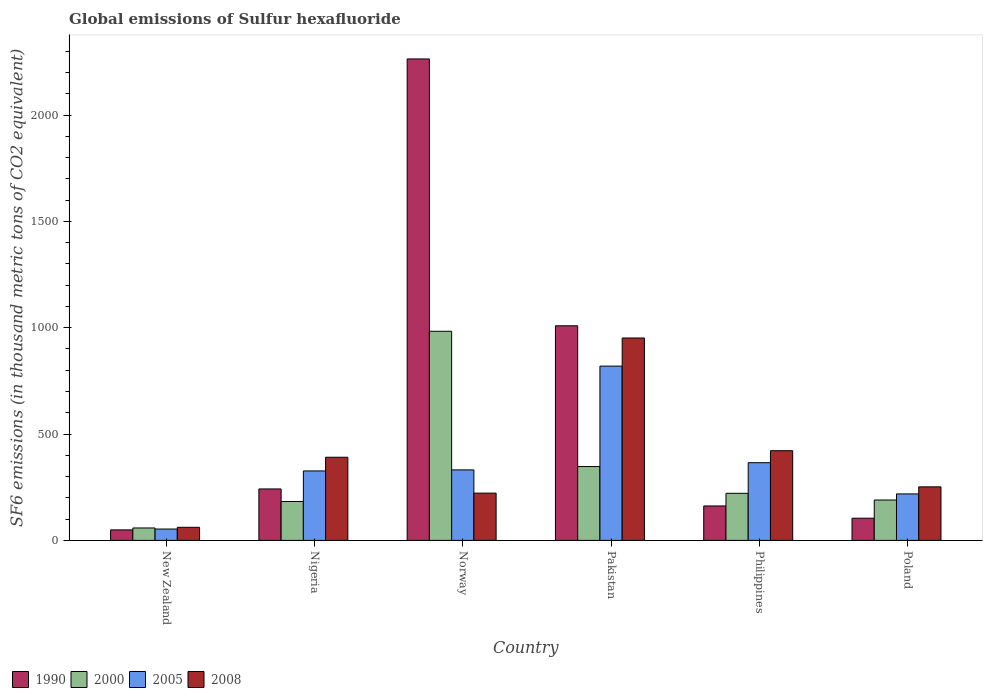How many bars are there on the 3rd tick from the left?
Your response must be concise. 4. What is the global emissions of Sulfur hexafluoride in 2000 in New Zealand?
Offer a terse response. 58.4. Across all countries, what is the maximum global emissions of Sulfur hexafluoride in 2000?
Keep it short and to the point. 983.2. Across all countries, what is the minimum global emissions of Sulfur hexafluoride in 2008?
Your response must be concise. 61.5. In which country was the global emissions of Sulfur hexafluoride in 2005 maximum?
Make the answer very short. Pakistan. In which country was the global emissions of Sulfur hexafluoride in 1990 minimum?
Provide a succinct answer. New Zealand. What is the total global emissions of Sulfur hexafluoride in 2005 in the graph?
Keep it short and to the point. 2114.6. What is the difference between the global emissions of Sulfur hexafluoride in 2000 in Nigeria and that in Poland?
Your answer should be compact. -7. What is the difference between the global emissions of Sulfur hexafluoride in 1990 in Pakistan and the global emissions of Sulfur hexafluoride in 2008 in Nigeria?
Make the answer very short. 618.1. What is the average global emissions of Sulfur hexafluoride in 2005 per country?
Ensure brevity in your answer.  352.43. What is the difference between the global emissions of Sulfur hexafluoride of/in 2008 and global emissions of Sulfur hexafluoride of/in 2000 in Philippines?
Your answer should be compact. 200.3. In how many countries, is the global emissions of Sulfur hexafluoride in 2005 greater than 900 thousand metric tons?
Your answer should be compact. 0. What is the ratio of the global emissions of Sulfur hexafluoride in 2000 in New Zealand to that in Pakistan?
Provide a succinct answer. 0.17. Is the global emissions of Sulfur hexafluoride in 2000 in Nigeria less than that in Norway?
Your answer should be compact. Yes. Is the difference between the global emissions of Sulfur hexafluoride in 2008 in Norway and Philippines greater than the difference between the global emissions of Sulfur hexafluoride in 2000 in Norway and Philippines?
Keep it short and to the point. No. What is the difference between the highest and the second highest global emissions of Sulfur hexafluoride in 2005?
Your answer should be compact. -488. What is the difference between the highest and the lowest global emissions of Sulfur hexafluoride in 2008?
Offer a terse response. 890.1. In how many countries, is the global emissions of Sulfur hexafluoride in 2005 greater than the average global emissions of Sulfur hexafluoride in 2005 taken over all countries?
Your answer should be very brief. 2. Is the sum of the global emissions of Sulfur hexafluoride in 2008 in Nigeria and Norway greater than the maximum global emissions of Sulfur hexafluoride in 1990 across all countries?
Offer a terse response. No. Is it the case that in every country, the sum of the global emissions of Sulfur hexafluoride in 2000 and global emissions of Sulfur hexafluoride in 2005 is greater than the sum of global emissions of Sulfur hexafluoride in 1990 and global emissions of Sulfur hexafluoride in 2008?
Your answer should be compact. No. What is the difference between two consecutive major ticks on the Y-axis?
Keep it short and to the point. 500. Does the graph contain any zero values?
Your answer should be very brief. No. Where does the legend appear in the graph?
Make the answer very short. Bottom left. What is the title of the graph?
Give a very brief answer. Global emissions of Sulfur hexafluoride. What is the label or title of the Y-axis?
Your answer should be compact. SF6 emissions (in thousand metric tons of CO2 equivalent). What is the SF6 emissions (in thousand metric tons of CO2 equivalent) of 1990 in New Zealand?
Provide a succinct answer. 49.4. What is the SF6 emissions (in thousand metric tons of CO2 equivalent) in 2000 in New Zealand?
Your answer should be very brief. 58.4. What is the SF6 emissions (in thousand metric tons of CO2 equivalent) in 2005 in New Zealand?
Offer a terse response. 53.4. What is the SF6 emissions (in thousand metric tons of CO2 equivalent) of 2008 in New Zealand?
Keep it short and to the point. 61.5. What is the SF6 emissions (in thousand metric tons of CO2 equivalent) in 1990 in Nigeria?
Ensure brevity in your answer.  241.9. What is the SF6 emissions (in thousand metric tons of CO2 equivalent) in 2000 in Nigeria?
Your answer should be very brief. 182.8. What is the SF6 emissions (in thousand metric tons of CO2 equivalent) in 2005 in Nigeria?
Your response must be concise. 326.6. What is the SF6 emissions (in thousand metric tons of CO2 equivalent) of 2008 in Nigeria?
Ensure brevity in your answer.  390.9. What is the SF6 emissions (in thousand metric tons of CO2 equivalent) in 1990 in Norway?
Provide a short and direct response. 2263.6. What is the SF6 emissions (in thousand metric tons of CO2 equivalent) in 2000 in Norway?
Ensure brevity in your answer.  983.2. What is the SF6 emissions (in thousand metric tons of CO2 equivalent) in 2005 in Norway?
Provide a succinct answer. 331.4. What is the SF6 emissions (in thousand metric tons of CO2 equivalent) of 2008 in Norway?
Provide a succinct answer. 222.2. What is the SF6 emissions (in thousand metric tons of CO2 equivalent) in 1990 in Pakistan?
Your answer should be compact. 1009. What is the SF6 emissions (in thousand metric tons of CO2 equivalent) of 2000 in Pakistan?
Your answer should be compact. 347.2. What is the SF6 emissions (in thousand metric tons of CO2 equivalent) of 2005 in Pakistan?
Your answer should be compact. 819.4. What is the SF6 emissions (in thousand metric tons of CO2 equivalent) in 2008 in Pakistan?
Ensure brevity in your answer.  951.6. What is the SF6 emissions (in thousand metric tons of CO2 equivalent) in 1990 in Philippines?
Ensure brevity in your answer.  161.9. What is the SF6 emissions (in thousand metric tons of CO2 equivalent) of 2000 in Philippines?
Your answer should be compact. 221.4. What is the SF6 emissions (in thousand metric tons of CO2 equivalent) of 2005 in Philippines?
Offer a very short reply. 365.3. What is the SF6 emissions (in thousand metric tons of CO2 equivalent) of 2008 in Philippines?
Ensure brevity in your answer.  421.7. What is the SF6 emissions (in thousand metric tons of CO2 equivalent) of 1990 in Poland?
Your response must be concise. 104.3. What is the SF6 emissions (in thousand metric tons of CO2 equivalent) in 2000 in Poland?
Offer a terse response. 189.8. What is the SF6 emissions (in thousand metric tons of CO2 equivalent) in 2005 in Poland?
Make the answer very short. 218.5. What is the SF6 emissions (in thousand metric tons of CO2 equivalent) in 2008 in Poland?
Your answer should be compact. 251.7. Across all countries, what is the maximum SF6 emissions (in thousand metric tons of CO2 equivalent) in 1990?
Give a very brief answer. 2263.6. Across all countries, what is the maximum SF6 emissions (in thousand metric tons of CO2 equivalent) in 2000?
Offer a terse response. 983.2. Across all countries, what is the maximum SF6 emissions (in thousand metric tons of CO2 equivalent) in 2005?
Give a very brief answer. 819.4. Across all countries, what is the maximum SF6 emissions (in thousand metric tons of CO2 equivalent) of 2008?
Your response must be concise. 951.6. Across all countries, what is the minimum SF6 emissions (in thousand metric tons of CO2 equivalent) of 1990?
Offer a very short reply. 49.4. Across all countries, what is the minimum SF6 emissions (in thousand metric tons of CO2 equivalent) in 2000?
Keep it short and to the point. 58.4. Across all countries, what is the minimum SF6 emissions (in thousand metric tons of CO2 equivalent) in 2005?
Your answer should be compact. 53.4. Across all countries, what is the minimum SF6 emissions (in thousand metric tons of CO2 equivalent) of 2008?
Your answer should be compact. 61.5. What is the total SF6 emissions (in thousand metric tons of CO2 equivalent) in 1990 in the graph?
Your response must be concise. 3830.1. What is the total SF6 emissions (in thousand metric tons of CO2 equivalent) of 2000 in the graph?
Keep it short and to the point. 1982.8. What is the total SF6 emissions (in thousand metric tons of CO2 equivalent) of 2005 in the graph?
Give a very brief answer. 2114.6. What is the total SF6 emissions (in thousand metric tons of CO2 equivalent) of 2008 in the graph?
Give a very brief answer. 2299.6. What is the difference between the SF6 emissions (in thousand metric tons of CO2 equivalent) of 1990 in New Zealand and that in Nigeria?
Provide a short and direct response. -192.5. What is the difference between the SF6 emissions (in thousand metric tons of CO2 equivalent) in 2000 in New Zealand and that in Nigeria?
Provide a short and direct response. -124.4. What is the difference between the SF6 emissions (in thousand metric tons of CO2 equivalent) of 2005 in New Zealand and that in Nigeria?
Your answer should be very brief. -273.2. What is the difference between the SF6 emissions (in thousand metric tons of CO2 equivalent) of 2008 in New Zealand and that in Nigeria?
Provide a short and direct response. -329.4. What is the difference between the SF6 emissions (in thousand metric tons of CO2 equivalent) in 1990 in New Zealand and that in Norway?
Your response must be concise. -2214.2. What is the difference between the SF6 emissions (in thousand metric tons of CO2 equivalent) in 2000 in New Zealand and that in Norway?
Your answer should be compact. -924.8. What is the difference between the SF6 emissions (in thousand metric tons of CO2 equivalent) in 2005 in New Zealand and that in Norway?
Provide a succinct answer. -278. What is the difference between the SF6 emissions (in thousand metric tons of CO2 equivalent) of 2008 in New Zealand and that in Norway?
Ensure brevity in your answer.  -160.7. What is the difference between the SF6 emissions (in thousand metric tons of CO2 equivalent) in 1990 in New Zealand and that in Pakistan?
Provide a succinct answer. -959.6. What is the difference between the SF6 emissions (in thousand metric tons of CO2 equivalent) of 2000 in New Zealand and that in Pakistan?
Give a very brief answer. -288.8. What is the difference between the SF6 emissions (in thousand metric tons of CO2 equivalent) in 2005 in New Zealand and that in Pakistan?
Provide a succinct answer. -766. What is the difference between the SF6 emissions (in thousand metric tons of CO2 equivalent) in 2008 in New Zealand and that in Pakistan?
Your response must be concise. -890.1. What is the difference between the SF6 emissions (in thousand metric tons of CO2 equivalent) in 1990 in New Zealand and that in Philippines?
Your answer should be compact. -112.5. What is the difference between the SF6 emissions (in thousand metric tons of CO2 equivalent) in 2000 in New Zealand and that in Philippines?
Offer a very short reply. -163. What is the difference between the SF6 emissions (in thousand metric tons of CO2 equivalent) in 2005 in New Zealand and that in Philippines?
Ensure brevity in your answer.  -311.9. What is the difference between the SF6 emissions (in thousand metric tons of CO2 equivalent) in 2008 in New Zealand and that in Philippines?
Offer a terse response. -360.2. What is the difference between the SF6 emissions (in thousand metric tons of CO2 equivalent) in 1990 in New Zealand and that in Poland?
Make the answer very short. -54.9. What is the difference between the SF6 emissions (in thousand metric tons of CO2 equivalent) in 2000 in New Zealand and that in Poland?
Give a very brief answer. -131.4. What is the difference between the SF6 emissions (in thousand metric tons of CO2 equivalent) of 2005 in New Zealand and that in Poland?
Provide a short and direct response. -165.1. What is the difference between the SF6 emissions (in thousand metric tons of CO2 equivalent) of 2008 in New Zealand and that in Poland?
Offer a terse response. -190.2. What is the difference between the SF6 emissions (in thousand metric tons of CO2 equivalent) of 1990 in Nigeria and that in Norway?
Keep it short and to the point. -2021.7. What is the difference between the SF6 emissions (in thousand metric tons of CO2 equivalent) in 2000 in Nigeria and that in Norway?
Offer a terse response. -800.4. What is the difference between the SF6 emissions (in thousand metric tons of CO2 equivalent) of 2005 in Nigeria and that in Norway?
Your answer should be compact. -4.8. What is the difference between the SF6 emissions (in thousand metric tons of CO2 equivalent) of 2008 in Nigeria and that in Norway?
Offer a very short reply. 168.7. What is the difference between the SF6 emissions (in thousand metric tons of CO2 equivalent) of 1990 in Nigeria and that in Pakistan?
Provide a succinct answer. -767.1. What is the difference between the SF6 emissions (in thousand metric tons of CO2 equivalent) of 2000 in Nigeria and that in Pakistan?
Keep it short and to the point. -164.4. What is the difference between the SF6 emissions (in thousand metric tons of CO2 equivalent) in 2005 in Nigeria and that in Pakistan?
Provide a succinct answer. -492.8. What is the difference between the SF6 emissions (in thousand metric tons of CO2 equivalent) of 2008 in Nigeria and that in Pakistan?
Ensure brevity in your answer.  -560.7. What is the difference between the SF6 emissions (in thousand metric tons of CO2 equivalent) in 2000 in Nigeria and that in Philippines?
Your answer should be very brief. -38.6. What is the difference between the SF6 emissions (in thousand metric tons of CO2 equivalent) in 2005 in Nigeria and that in Philippines?
Ensure brevity in your answer.  -38.7. What is the difference between the SF6 emissions (in thousand metric tons of CO2 equivalent) of 2008 in Nigeria and that in Philippines?
Offer a very short reply. -30.8. What is the difference between the SF6 emissions (in thousand metric tons of CO2 equivalent) of 1990 in Nigeria and that in Poland?
Offer a terse response. 137.6. What is the difference between the SF6 emissions (in thousand metric tons of CO2 equivalent) in 2000 in Nigeria and that in Poland?
Offer a very short reply. -7. What is the difference between the SF6 emissions (in thousand metric tons of CO2 equivalent) of 2005 in Nigeria and that in Poland?
Your answer should be compact. 108.1. What is the difference between the SF6 emissions (in thousand metric tons of CO2 equivalent) of 2008 in Nigeria and that in Poland?
Make the answer very short. 139.2. What is the difference between the SF6 emissions (in thousand metric tons of CO2 equivalent) in 1990 in Norway and that in Pakistan?
Your answer should be compact. 1254.6. What is the difference between the SF6 emissions (in thousand metric tons of CO2 equivalent) of 2000 in Norway and that in Pakistan?
Keep it short and to the point. 636. What is the difference between the SF6 emissions (in thousand metric tons of CO2 equivalent) of 2005 in Norway and that in Pakistan?
Provide a succinct answer. -488. What is the difference between the SF6 emissions (in thousand metric tons of CO2 equivalent) in 2008 in Norway and that in Pakistan?
Give a very brief answer. -729.4. What is the difference between the SF6 emissions (in thousand metric tons of CO2 equivalent) of 1990 in Norway and that in Philippines?
Your answer should be compact. 2101.7. What is the difference between the SF6 emissions (in thousand metric tons of CO2 equivalent) in 2000 in Norway and that in Philippines?
Ensure brevity in your answer.  761.8. What is the difference between the SF6 emissions (in thousand metric tons of CO2 equivalent) in 2005 in Norway and that in Philippines?
Provide a succinct answer. -33.9. What is the difference between the SF6 emissions (in thousand metric tons of CO2 equivalent) of 2008 in Norway and that in Philippines?
Give a very brief answer. -199.5. What is the difference between the SF6 emissions (in thousand metric tons of CO2 equivalent) of 1990 in Norway and that in Poland?
Offer a very short reply. 2159.3. What is the difference between the SF6 emissions (in thousand metric tons of CO2 equivalent) of 2000 in Norway and that in Poland?
Provide a short and direct response. 793.4. What is the difference between the SF6 emissions (in thousand metric tons of CO2 equivalent) in 2005 in Norway and that in Poland?
Offer a terse response. 112.9. What is the difference between the SF6 emissions (in thousand metric tons of CO2 equivalent) of 2008 in Norway and that in Poland?
Your answer should be compact. -29.5. What is the difference between the SF6 emissions (in thousand metric tons of CO2 equivalent) in 1990 in Pakistan and that in Philippines?
Make the answer very short. 847.1. What is the difference between the SF6 emissions (in thousand metric tons of CO2 equivalent) in 2000 in Pakistan and that in Philippines?
Give a very brief answer. 125.8. What is the difference between the SF6 emissions (in thousand metric tons of CO2 equivalent) of 2005 in Pakistan and that in Philippines?
Give a very brief answer. 454.1. What is the difference between the SF6 emissions (in thousand metric tons of CO2 equivalent) of 2008 in Pakistan and that in Philippines?
Your answer should be compact. 529.9. What is the difference between the SF6 emissions (in thousand metric tons of CO2 equivalent) in 1990 in Pakistan and that in Poland?
Your answer should be very brief. 904.7. What is the difference between the SF6 emissions (in thousand metric tons of CO2 equivalent) of 2000 in Pakistan and that in Poland?
Offer a terse response. 157.4. What is the difference between the SF6 emissions (in thousand metric tons of CO2 equivalent) in 2005 in Pakistan and that in Poland?
Provide a succinct answer. 600.9. What is the difference between the SF6 emissions (in thousand metric tons of CO2 equivalent) of 2008 in Pakistan and that in Poland?
Ensure brevity in your answer.  699.9. What is the difference between the SF6 emissions (in thousand metric tons of CO2 equivalent) of 1990 in Philippines and that in Poland?
Offer a terse response. 57.6. What is the difference between the SF6 emissions (in thousand metric tons of CO2 equivalent) in 2000 in Philippines and that in Poland?
Give a very brief answer. 31.6. What is the difference between the SF6 emissions (in thousand metric tons of CO2 equivalent) of 2005 in Philippines and that in Poland?
Ensure brevity in your answer.  146.8. What is the difference between the SF6 emissions (in thousand metric tons of CO2 equivalent) of 2008 in Philippines and that in Poland?
Offer a terse response. 170. What is the difference between the SF6 emissions (in thousand metric tons of CO2 equivalent) of 1990 in New Zealand and the SF6 emissions (in thousand metric tons of CO2 equivalent) of 2000 in Nigeria?
Offer a terse response. -133.4. What is the difference between the SF6 emissions (in thousand metric tons of CO2 equivalent) in 1990 in New Zealand and the SF6 emissions (in thousand metric tons of CO2 equivalent) in 2005 in Nigeria?
Offer a terse response. -277.2. What is the difference between the SF6 emissions (in thousand metric tons of CO2 equivalent) in 1990 in New Zealand and the SF6 emissions (in thousand metric tons of CO2 equivalent) in 2008 in Nigeria?
Offer a very short reply. -341.5. What is the difference between the SF6 emissions (in thousand metric tons of CO2 equivalent) in 2000 in New Zealand and the SF6 emissions (in thousand metric tons of CO2 equivalent) in 2005 in Nigeria?
Keep it short and to the point. -268.2. What is the difference between the SF6 emissions (in thousand metric tons of CO2 equivalent) in 2000 in New Zealand and the SF6 emissions (in thousand metric tons of CO2 equivalent) in 2008 in Nigeria?
Your answer should be compact. -332.5. What is the difference between the SF6 emissions (in thousand metric tons of CO2 equivalent) of 2005 in New Zealand and the SF6 emissions (in thousand metric tons of CO2 equivalent) of 2008 in Nigeria?
Keep it short and to the point. -337.5. What is the difference between the SF6 emissions (in thousand metric tons of CO2 equivalent) of 1990 in New Zealand and the SF6 emissions (in thousand metric tons of CO2 equivalent) of 2000 in Norway?
Provide a succinct answer. -933.8. What is the difference between the SF6 emissions (in thousand metric tons of CO2 equivalent) of 1990 in New Zealand and the SF6 emissions (in thousand metric tons of CO2 equivalent) of 2005 in Norway?
Your response must be concise. -282. What is the difference between the SF6 emissions (in thousand metric tons of CO2 equivalent) in 1990 in New Zealand and the SF6 emissions (in thousand metric tons of CO2 equivalent) in 2008 in Norway?
Your answer should be compact. -172.8. What is the difference between the SF6 emissions (in thousand metric tons of CO2 equivalent) in 2000 in New Zealand and the SF6 emissions (in thousand metric tons of CO2 equivalent) in 2005 in Norway?
Ensure brevity in your answer.  -273. What is the difference between the SF6 emissions (in thousand metric tons of CO2 equivalent) in 2000 in New Zealand and the SF6 emissions (in thousand metric tons of CO2 equivalent) in 2008 in Norway?
Ensure brevity in your answer.  -163.8. What is the difference between the SF6 emissions (in thousand metric tons of CO2 equivalent) of 2005 in New Zealand and the SF6 emissions (in thousand metric tons of CO2 equivalent) of 2008 in Norway?
Ensure brevity in your answer.  -168.8. What is the difference between the SF6 emissions (in thousand metric tons of CO2 equivalent) in 1990 in New Zealand and the SF6 emissions (in thousand metric tons of CO2 equivalent) in 2000 in Pakistan?
Ensure brevity in your answer.  -297.8. What is the difference between the SF6 emissions (in thousand metric tons of CO2 equivalent) of 1990 in New Zealand and the SF6 emissions (in thousand metric tons of CO2 equivalent) of 2005 in Pakistan?
Provide a short and direct response. -770. What is the difference between the SF6 emissions (in thousand metric tons of CO2 equivalent) of 1990 in New Zealand and the SF6 emissions (in thousand metric tons of CO2 equivalent) of 2008 in Pakistan?
Offer a very short reply. -902.2. What is the difference between the SF6 emissions (in thousand metric tons of CO2 equivalent) of 2000 in New Zealand and the SF6 emissions (in thousand metric tons of CO2 equivalent) of 2005 in Pakistan?
Your response must be concise. -761. What is the difference between the SF6 emissions (in thousand metric tons of CO2 equivalent) of 2000 in New Zealand and the SF6 emissions (in thousand metric tons of CO2 equivalent) of 2008 in Pakistan?
Your response must be concise. -893.2. What is the difference between the SF6 emissions (in thousand metric tons of CO2 equivalent) in 2005 in New Zealand and the SF6 emissions (in thousand metric tons of CO2 equivalent) in 2008 in Pakistan?
Make the answer very short. -898.2. What is the difference between the SF6 emissions (in thousand metric tons of CO2 equivalent) of 1990 in New Zealand and the SF6 emissions (in thousand metric tons of CO2 equivalent) of 2000 in Philippines?
Your response must be concise. -172. What is the difference between the SF6 emissions (in thousand metric tons of CO2 equivalent) in 1990 in New Zealand and the SF6 emissions (in thousand metric tons of CO2 equivalent) in 2005 in Philippines?
Provide a short and direct response. -315.9. What is the difference between the SF6 emissions (in thousand metric tons of CO2 equivalent) in 1990 in New Zealand and the SF6 emissions (in thousand metric tons of CO2 equivalent) in 2008 in Philippines?
Offer a very short reply. -372.3. What is the difference between the SF6 emissions (in thousand metric tons of CO2 equivalent) in 2000 in New Zealand and the SF6 emissions (in thousand metric tons of CO2 equivalent) in 2005 in Philippines?
Your response must be concise. -306.9. What is the difference between the SF6 emissions (in thousand metric tons of CO2 equivalent) of 2000 in New Zealand and the SF6 emissions (in thousand metric tons of CO2 equivalent) of 2008 in Philippines?
Offer a terse response. -363.3. What is the difference between the SF6 emissions (in thousand metric tons of CO2 equivalent) of 2005 in New Zealand and the SF6 emissions (in thousand metric tons of CO2 equivalent) of 2008 in Philippines?
Make the answer very short. -368.3. What is the difference between the SF6 emissions (in thousand metric tons of CO2 equivalent) of 1990 in New Zealand and the SF6 emissions (in thousand metric tons of CO2 equivalent) of 2000 in Poland?
Your answer should be very brief. -140.4. What is the difference between the SF6 emissions (in thousand metric tons of CO2 equivalent) of 1990 in New Zealand and the SF6 emissions (in thousand metric tons of CO2 equivalent) of 2005 in Poland?
Keep it short and to the point. -169.1. What is the difference between the SF6 emissions (in thousand metric tons of CO2 equivalent) in 1990 in New Zealand and the SF6 emissions (in thousand metric tons of CO2 equivalent) in 2008 in Poland?
Provide a short and direct response. -202.3. What is the difference between the SF6 emissions (in thousand metric tons of CO2 equivalent) of 2000 in New Zealand and the SF6 emissions (in thousand metric tons of CO2 equivalent) of 2005 in Poland?
Make the answer very short. -160.1. What is the difference between the SF6 emissions (in thousand metric tons of CO2 equivalent) in 2000 in New Zealand and the SF6 emissions (in thousand metric tons of CO2 equivalent) in 2008 in Poland?
Make the answer very short. -193.3. What is the difference between the SF6 emissions (in thousand metric tons of CO2 equivalent) in 2005 in New Zealand and the SF6 emissions (in thousand metric tons of CO2 equivalent) in 2008 in Poland?
Provide a succinct answer. -198.3. What is the difference between the SF6 emissions (in thousand metric tons of CO2 equivalent) of 1990 in Nigeria and the SF6 emissions (in thousand metric tons of CO2 equivalent) of 2000 in Norway?
Give a very brief answer. -741.3. What is the difference between the SF6 emissions (in thousand metric tons of CO2 equivalent) in 1990 in Nigeria and the SF6 emissions (in thousand metric tons of CO2 equivalent) in 2005 in Norway?
Make the answer very short. -89.5. What is the difference between the SF6 emissions (in thousand metric tons of CO2 equivalent) of 2000 in Nigeria and the SF6 emissions (in thousand metric tons of CO2 equivalent) of 2005 in Norway?
Your response must be concise. -148.6. What is the difference between the SF6 emissions (in thousand metric tons of CO2 equivalent) of 2000 in Nigeria and the SF6 emissions (in thousand metric tons of CO2 equivalent) of 2008 in Norway?
Keep it short and to the point. -39.4. What is the difference between the SF6 emissions (in thousand metric tons of CO2 equivalent) in 2005 in Nigeria and the SF6 emissions (in thousand metric tons of CO2 equivalent) in 2008 in Norway?
Provide a short and direct response. 104.4. What is the difference between the SF6 emissions (in thousand metric tons of CO2 equivalent) of 1990 in Nigeria and the SF6 emissions (in thousand metric tons of CO2 equivalent) of 2000 in Pakistan?
Your answer should be compact. -105.3. What is the difference between the SF6 emissions (in thousand metric tons of CO2 equivalent) in 1990 in Nigeria and the SF6 emissions (in thousand metric tons of CO2 equivalent) in 2005 in Pakistan?
Offer a very short reply. -577.5. What is the difference between the SF6 emissions (in thousand metric tons of CO2 equivalent) in 1990 in Nigeria and the SF6 emissions (in thousand metric tons of CO2 equivalent) in 2008 in Pakistan?
Keep it short and to the point. -709.7. What is the difference between the SF6 emissions (in thousand metric tons of CO2 equivalent) in 2000 in Nigeria and the SF6 emissions (in thousand metric tons of CO2 equivalent) in 2005 in Pakistan?
Ensure brevity in your answer.  -636.6. What is the difference between the SF6 emissions (in thousand metric tons of CO2 equivalent) of 2000 in Nigeria and the SF6 emissions (in thousand metric tons of CO2 equivalent) of 2008 in Pakistan?
Your response must be concise. -768.8. What is the difference between the SF6 emissions (in thousand metric tons of CO2 equivalent) in 2005 in Nigeria and the SF6 emissions (in thousand metric tons of CO2 equivalent) in 2008 in Pakistan?
Your answer should be compact. -625. What is the difference between the SF6 emissions (in thousand metric tons of CO2 equivalent) in 1990 in Nigeria and the SF6 emissions (in thousand metric tons of CO2 equivalent) in 2000 in Philippines?
Keep it short and to the point. 20.5. What is the difference between the SF6 emissions (in thousand metric tons of CO2 equivalent) in 1990 in Nigeria and the SF6 emissions (in thousand metric tons of CO2 equivalent) in 2005 in Philippines?
Offer a terse response. -123.4. What is the difference between the SF6 emissions (in thousand metric tons of CO2 equivalent) of 1990 in Nigeria and the SF6 emissions (in thousand metric tons of CO2 equivalent) of 2008 in Philippines?
Provide a short and direct response. -179.8. What is the difference between the SF6 emissions (in thousand metric tons of CO2 equivalent) of 2000 in Nigeria and the SF6 emissions (in thousand metric tons of CO2 equivalent) of 2005 in Philippines?
Ensure brevity in your answer.  -182.5. What is the difference between the SF6 emissions (in thousand metric tons of CO2 equivalent) in 2000 in Nigeria and the SF6 emissions (in thousand metric tons of CO2 equivalent) in 2008 in Philippines?
Give a very brief answer. -238.9. What is the difference between the SF6 emissions (in thousand metric tons of CO2 equivalent) in 2005 in Nigeria and the SF6 emissions (in thousand metric tons of CO2 equivalent) in 2008 in Philippines?
Make the answer very short. -95.1. What is the difference between the SF6 emissions (in thousand metric tons of CO2 equivalent) in 1990 in Nigeria and the SF6 emissions (in thousand metric tons of CO2 equivalent) in 2000 in Poland?
Your response must be concise. 52.1. What is the difference between the SF6 emissions (in thousand metric tons of CO2 equivalent) of 1990 in Nigeria and the SF6 emissions (in thousand metric tons of CO2 equivalent) of 2005 in Poland?
Your answer should be very brief. 23.4. What is the difference between the SF6 emissions (in thousand metric tons of CO2 equivalent) in 1990 in Nigeria and the SF6 emissions (in thousand metric tons of CO2 equivalent) in 2008 in Poland?
Offer a very short reply. -9.8. What is the difference between the SF6 emissions (in thousand metric tons of CO2 equivalent) of 2000 in Nigeria and the SF6 emissions (in thousand metric tons of CO2 equivalent) of 2005 in Poland?
Keep it short and to the point. -35.7. What is the difference between the SF6 emissions (in thousand metric tons of CO2 equivalent) of 2000 in Nigeria and the SF6 emissions (in thousand metric tons of CO2 equivalent) of 2008 in Poland?
Provide a short and direct response. -68.9. What is the difference between the SF6 emissions (in thousand metric tons of CO2 equivalent) in 2005 in Nigeria and the SF6 emissions (in thousand metric tons of CO2 equivalent) in 2008 in Poland?
Make the answer very short. 74.9. What is the difference between the SF6 emissions (in thousand metric tons of CO2 equivalent) of 1990 in Norway and the SF6 emissions (in thousand metric tons of CO2 equivalent) of 2000 in Pakistan?
Ensure brevity in your answer.  1916.4. What is the difference between the SF6 emissions (in thousand metric tons of CO2 equivalent) in 1990 in Norway and the SF6 emissions (in thousand metric tons of CO2 equivalent) in 2005 in Pakistan?
Your answer should be compact. 1444.2. What is the difference between the SF6 emissions (in thousand metric tons of CO2 equivalent) in 1990 in Norway and the SF6 emissions (in thousand metric tons of CO2 equivalent) in 2008 in Pakistan?
Provide a succinct answer. 1312. What is the difference between the SF6 emissions (in thousand metric tons of CO2 equivalent) in 2000 in Norway and the SF6 emissions (in thousand metric tons of CO2 equivalent) in 2005 in Pakistan?
Provide a succinct answer. 163.8. What is the difference between the SF6 emissions (in thousand metric tons of CO2 equivalent) in 2000 in Norway and the SF6 emissions (in thousand metric tons of CO2 equivalent) in 2008 in Pakistan?
Provide a succinct answer. 31.6. What is the difference between the SF6 emissions (in thousand metric tons of CO2 equivalent) in 2005 in Norway and the SF6 emissions (in thousand metric tons of CO2 equivalent) in 2008 in Pakistan?
Ensure brevity in your answer.  -620.2. What is the difference between the SF6 emissions (in thousand metric tons of CO2 equivalent) of 1990 in Norway and the SF6 emissions (in thousand metric tons of CO2 equivalent) of 2000 in Philippines?
Make the answer very short. 2042.2. What is the difference between the SF6 emissions (in thousand metric tons of CO2 equivalent) in 1990 in Norway and the SF6 emissions (in thousand metric tons of CO2 equivalent) in 2005 in Philippines?
Make the answer very short. 1898.3. What is the difference between the SF6 emissions (in thousand metric tons of CO2 equivalent) of 1990 in Norway and the SF6 emissions (in thousand metric tons of CO2 equivalent) of 2008 in Philippines?
Your answer should be compact. 1841.9. What is the difference between the SF6 emissions (in thousand metric tons of CO2 equivalent) of 2000 in Norway and the SF6 emissions (in thousand metric tons of CO2 equivalent) of 2005 in Philippines?
Offer a terse response. 617.9. What is the difference between the SF6 emissions (in thousand metric tons of CO2 equivalent) in 2000 in Norway and the SF6 emissions (in thousand metric tons of CO2 equivalent) in 2008 in Philippines?
Make the answer very short. 561.5. What is the difference between the SF6 emissions (in thousand metric tons of CO2 equivalent) in 2005 in Norway and the SF6 emissions (in thousand metric tons of CO2 equivalent) in 2008 in Philippines?
Offer a very short reply. -90.3. What is the difference between the SF6 emissions (in thousand metric tons of CO2 equivalent) of 1990 in Norway and the SF6 emissions (in thousand metric tons of CO2 equivalent) of 2000 in Poland?
Ensure brevity in your answer.  2073.8. What is the difference between the SF6 emissions (in thousand metric tons of CO2 equivalent) in 1990 in Norway and the SF6 emissions (in thousand metric tons of CO2 equivalent) in 2005 in Poland?
Ensure brevity in your answer.  2045.1. What is the difference between the SF6 emissions (in thousand metric tons of CO2 equivalent) in 1990 in Norway and the SF6 emissions (in thousand metric tons of CO2 equivalent) in 2008 in Poland?
Give a very brief answer. 2011.9. What is the difference between the SF6 emissions (in thousand metric tons of CO2 equivalent) of 2000 in Norway and the SF6 emissions (in thousand metric tons of CO2 equivalent) of 2005 in Poland?
Your response must be concise. 764.7. What is the difference between the SF6 emissions (in thousand metric tons of CO2 equivalent) of 2000 in Norway and the SF6 emissions (in thousand metric tons of CO2 equivalent) of 2008 in Poland?
Give a very brief answer. 731.5. What is the difference between the SF6 emissions (in thousand metric tons of CO2 equivalent) in 2005 in Norway and the SF6 emissions (in thousand metric tons of CO2 equivalent) in 2008 in Poland?
Your answer should be compact. 79.7. What is the difference between the SF6 emissions (in thousand metric tons of CO2 equivalent) of 1990 in Pakistan and the SF6 emissions (in thousand metric tons of CO2 equivalent) of 2000 in Philippines?
Ensure brevity in your answer.  787.6. What is the difference between the SF6 emissions (in thousand metric tons of CO2 equivalent) of 1990 in Pakistan and the SF6 emissions (in thousand metric tons of CO2 equivalent) of 2005 in Philippines?
Your response must be concise. 643.7. What is the difference between the SF6 emissions (in thousand metric tons of CO2 equivalent) of 1990 in Pakistan and the SF6 emissions (in thousand metric tons of CO2 equivalent) of 2008 in Philippines?
Your answer should be compact. 587.3. What is the difference between the SF6 emissions (in thousand metric tons of CO2 equivalent) in 2000 in Pakistan and the SF6 emissions (in thousand metric tons of CO2 equivalent) in 2005 in Philippines?
Provide a succinct answer. -18.1. What is the difference between the SF6 emissions (in thousand metric tons of CO2 equivalent) of 2000 in Pakistan and the SF6 emissions (in thousand metric tons of CO2 equivalent) of 2008 in Philippines?
Offer a terse response. -74.5. What is the difference between the SF6 emissions (in thousand metric tons of CO2 equivalent) in 2005 in Pakistan and the SF6 emissions (in thousand metric tons of CO2 equivalent) in 2008 in Philippines?
Provide a short and direct response. 397.7. What is the difference between the SF6 emissions (in thousand metric tons of CO2 equivalent) in 1990 in Pakistan and the SF6 emissions (in thousand metric tons of CO2 equivalent) in 2000 in Poland?
Provide a succinct answer. 819.2. What is the difference between the SF6 emissions (in thousand metric tons of CO2 equivalent) of 1990 in Pakistan and the SF6 emissions (in thousand metric tons of CO2 equivalent) of 2005 in Poland?
Give a very brief answer. 790.5. What is the difference between the SF6 emissions (in thousand metric tons of CO2 equivalent) of 1990 in Pakistan and the SF6 emissions (in thousand metric tons of CO2 equivalent) of 2008 in Poland?
Provide a succinct answer. 757.3. What is the difference between the SF6 emissions (in thousand metric tons of CO2 equivalent) of 2000 in Pakistan and the SF6 emissions (in thousand metric tons of CO2 equivalent) of 2005 in Poland?
Provide a succinct answer. 128.7. What is the difference between the SF6 emissions (in thousand metric tons of CO2 equivalent) of 2000 in Pakistan and the SF6 emissions (in thousand metric tons of CO2 equivalent) of 2008 in Poland?
Keep it short and to the point. 95.5. What is the difference between the SF6 emissions (in thousand metric tons of CO2 equivalent) in 2005 in Pakistan and the SF6 emissions (in thousand metric tons of CO2 equivalent) in 2008 in Poland?
Offer a terse response. 567.7. What is the difference between the SF6 emissions (in thousand metric tons of CO2 equivalent) in 1990 in Philippines and the SF6 emissions (in thousand metric tons of CO2 equivalent) in 2000 in Poland?
Your response must be concise. -27.9. What is the difference between the SF6 emissions (in thousand metric tons of CO2 equivalent) in 1990 in Philippines and the SF6 emissions (in thousand metric tons of CO2 equivalent) in 2005 in Poland?
Ensure brevity in your answer.  -56.6. What is the difference between the SF6 emissions (in thousand metric tons of CO2 equivalent) in 1990 in Philippines and the SF6 emissions (in thousand metric tons of CO2 equivalent) in 2008 in Poland?
Provide a succinct answer. -89.8. What is the difference between the SF6 emissions (in thousand metric tons of CO2 equivalent) in 2000 in Philippines and the SF6 emissions (in thousand metric tons of CO2 equivalent) in 2005 in Poland?
Offer a terse response. 2.9. What is the difference between the SF6 emissions (in thousand metric tons of CO2 equivalent) of 2000 in Philippines and the SF6 emissions (in thousand metric tons of CO2 equivalent) of 2008 in Poland?
Offer a terse response. -30.3. What is the difference between the SF6 emissions (in thousand metric tons of CO2 equivalent) in 2005 in Philippines and the SF6 emissions (in thousand metric tons of CO2 equivalent) in 2008 in Poland?
Offer a terse response. 113.6. What is the average SF6 emissions (in thousand metric tons of CO2 equivalent) in 1990 per country?
Your answer should be compact. 638.35. What is the average SF6 emissions (in thousand metric tons of CO2 equivalent) in 2000 per country?
Provide a short and direct response. 330.47. What is the average SF6 emissions (in thousand metric tons of CO2 equivalent) of 2005 per country?
Make the answer very short. 352.43. What is the average SF6 emissions (in thousand metric tons of CO2 equivalent) in 2008 per country?
Your answer should be very brief. 383.27. What is the difference between the SF6 emissions (in thousand metric tons of CO2 equivalent) of 1990 and SF6 emissions (in thousand metric tons of CO2 equivalent) of 2000 in New Zealand?
Keep it short and to the point. -9. What is the difference between the SF6 emissions (in thousand metric tons of CO2 equivalent) in 1990 and SF6 emissions (in thousand metric tons of CO2 equivalent) in 2005 in New Zealand?
Your response must be concise. -4. What is the difference between the SF6 emissions (in thousand metric tons of CO2 equivalent) of 2000 and SF6 emissions (in thousand metric tons of CO2 equivalent) of 2008 in New Zealand?
Ensure brevity in your answer.  -3.1. What is the difference between the SF6 emissions (in thousand metric tons of CO2 equivalent) of 1990 and SF6 emissions (in thousand metric tons of CO2 equivalent) of 2000 in Nigeria?
Offer a terse response. 59.1. What is the difference between the SF6 emissions (in thousand metric tons of CO2 equivalent) in 1990 and SF6 emissions (in thousand metric tons of CO2 equivalent) in 2005 in Nigeria?
Keep it short and to the point. -84.7. What is the difference between the SF6 emissions (in thousand metric tons of CO2 equivalent) of 1990 and SF6 emissions (in thousand metric tons of CO2 equivalent) of 2008 in Nigeria?
Give a very brief answer. -149. What is the difference between the SF6 emissions (in thousand metric tons of CO2 equivalent) in 2000 and SF6 emissions (in thousand metric tons of CO2 equivalent) in 2005 in Nigeria?
Make the answer very short. -143.8. What is the difference between the SF6 emissions (in thousand metric tons of CO2 equivalent) of 2000 and SF6 emissions (in thousand metric tons of CO2 equivalent) of 2008 in Nigeria?
Your response must be concise. -208.1. What is the difference between the SF6 emissions (in thousand metric tons of CO2 equivalent) of 2005 and SF6 emissions (in thousand metric tons of CO2 equivalent) of 2008 in Nigeria?
Give a very brief answer. -64.3. What is the difference between the SF6 emissions (in thousand metric tons of CO2 equivalent) in 1990 and SF6 emissions (in thousand metric tons of CO2 equivalent) in 2000 in Norway?
Ensure brevity in your answer.  1280.4. What is the difference between the SF6 emissions (in thousand metric tons of CO2 equivalent) in 1990 and SF6 emissions (in thousand metric tons of CO2 equivalent) in 2005 in Norway?
Provide a short and direct response. 1932.2. What is the difference between the SF6 emissions (in thousand metric tons of CO2 equivalent) in 1990 and SF6 emissions (in thousand metric tons of CO2 equivalent) in 2008 in Norway?
Keep it short and to the point. 2041.4. What is the difference between the SF6 emissions (in thousand metric tons of CO2 equivalent) in 2000 and SF6 emissions (in thousand metric tons of CO2 equivalent) in 2005 in Norway?
Keep it short and to the point. 651.8. What is the difference between the SF6 emissions (in thousand metric tons of CO2 equivalent) of 2000 and SF6 emissions (in thousand metric tons of CO2 equivalent) of 2008 in Norway?
Your answer should be compact. 761. What is the difference between the SF6 emissions (in thousand metric tons of CO2 equivalent) of 2005 and SF6 emissions (in thousand metric tons of CO2 equivalent) of 2008 in Norway?
Provide a succinct answer. 109.2. What is the difference between the SF6 emissions (in thousand metric tons of CO2 equivalent) of 1990 and SF6 emissions (in thousand metric tons of CO2 equivalent) of 2000 in Pakistan?
Your answer should be very brief. 661.8. What is the difference between the SF6 emissions (in thousand metric tons of CO2 equivalent) in 1990 and SF6 emissions (in thousand metric tons of CO2 equivalent) in 2005 in Pakistan?
Give a very brief answer. 189.6. What is the difference between the SF6 emissions (in thousand metric tons of CO2 equivalent) of 1990 and SF6 emissions (in thousand metric tons of CO2 equivalent) of 2008 in Pakistan?
Your answer should be very brief. 57.4. What is the difference between the SF6 emissions (in thousand metric tons of CO2 equivalent) in 2000 and SF6 emissions (in thousand metric tons of CO2 equivalent) in 2005 in Pakistan?
Your answer should be compact. -472.2. What is the difference between the SF6 emissions (in thousand metric tons of CO2 equivalent) of 2000 and SF6 emissions (in thousand metric tons of CO2 equivalent) of 2008 in Pakistan?
Offer a very short reply. -604.4. What is the difference between the SF6 emissions (in thousand metric tons of CO2 equivalent) in 2005 and SF6 emissions (in thousand metric tons of CO2 equivalent) in 2008 in Pakistan?
Ensure brevity in your answer.  -132.2. What is the difference between the SF6 emissions (in thousand metric tons of CO2 equivalent) in 1990 and SF6 emissions (in thousand metric tons of CO2 equivalent) in 2000 in Philippines?
Offer a terse response. -59.5. What is the difference between the SF6 emissions (in thousand metric tons of CO2 equivalent) in 1990 and SF6 emissions (in thousand metric tons of CO2 equivalent) in 2005 in Philippines?
Your answer should be compact. -203.4. What is the difference between the SF6 emissions (in thousand metric tons of CO2 equivalent) of 1990 and SF6 emissions (in thousand metric tons of CO2 equivalent) of 2008 in Philippines?
Your answer should be very brief. -259.8. What is the difference between the SF6 emissions (in thousand metric tons of CO2 equivalent) of 2000 and SF6 emissions (in thousand metric tons of CO2 equivalent) of 2005 in Philippines?
Ensure brevity in your answer.  -143.9. What is the difference between the SF6 emissions (in thousand metric tons of CO2 equivalent) of 2000 and SF6 emissions (in thousand metric tons of CO2 equivalent) of 2008 in Philippines?
Your response must be concise. -200.3. What is the difference between the SF6 emissions (in thousand metric tons of CO2 equivalent) of 2005 and SF6 emissions (in thousand metric tons of CO2 equivalent) of 2008 in Philippines?
Your answer should be very brief. -56.4. What is the difference between the SF6 emissions (in thousand metric tons of CO2 equivalent) of 1990 and SF6 emissions (in thousand metric tons of CO2 equivalent) of 2000 in Poland?
Provide a succinct answer. -85.5. What is the difference between the SF6 emissions (in thousand metric tons of CO2 equivalent) of 1990 and SF6 emissions (in thousand metric tons of CO2 equivalent) of 2005 in Poland?
Ensure brevity in your answer.  -114.2. What is the difference between the SF6 emissions (in thousand metric tons of CO2 equivalent) of 1990 and SF6 emissions (in thousand metric tons of CO2 equivalent) of 2008 in Poland?
Offer a very short reply. -147.4. What is the difference between the SF6 emissions (in thousand metric tons of CO2 equivalent) in 2000 and SF6 emissions (in thousand metric tons of CO2 equivalent) in 2005 in Poland?
Make the answer very short. -28.7. What is the difference between the SF6 emissions (in thousand metric tons of CO2 equivalent) in 2000 and SF6 emissions (in thousand metric tons of CO2 equivalent) in 2008 in Poland?
Your response must be concise. -61.9. What is the difference between the SF6 emissions (in thousand metric tons of CO2 equivalent) in 2005 and SF6 emissions (in thousand metric tons of CO2 equivalent) in 2008 in Poland?
Offer a very short reply. -33.2. What is the ratio of the SF6 emissions (in thousand metric tons of CO2 equivalent) in 1990 in New Zealand to that in Nigeria?
Keep it short and to the point. 0.2. What is the ratio of the SF6 emissions (in thousand metric tons of CO2 equivalent) in 2000 in New Zealand to that in Nigeria?
Ensure brevity in your answer.  0.32. What is the ratio of the SF6 emissions (in thousand metric tons of CO2 equivalent) in 2005 in New Zealand to that in Nigeria?
Keep it short and to the point. 0.16. What is the ratio of the SF6 emissions (in thousand metric tons of CO2 equivalent) in 2008 in New Zealand to that in Nigeria?
Provide a succinct answer. 0.16. What is the ratio of the SF6 emissions (in thousand metric tons of CO2 equivalent) in 1990 in New Zealand to that in Norway?
Give a very brief answer. 0.02. What is the ratio of the SF6 emissions (in thousand metric tons of CO2 equivalent) in 2000 in New Zealand to that in Norway?
Offer a very short reply. 0.06. What is the ratio of the SF6 emissions (in thousand metric tons of CO2 equivalent) of 2005 in New Zealand to that in Norway?
Your response must be concise. 0.16. What is the ratio of the SF6 emissions (in thousand metric tons of CO2 equivalent) in 2008 in New Zealand to that in Norway?
Your answer should be very brief. 0.28. What is the ratio of the SF6 emissions (in thousand metric tons of CO2 equivalent) of 1990 in New Zealand to that in Pakistan?
Your answer should be compact. 0.05. What is the ratio of the SF6 emissions (in thousand metric tons of CO2 equivalent) of 2000 in New Zealand to that in Pakistan?
Keep it short and to the point. 0.17. What is the ratio of the SF6 emissions (in thousand metric tons of CO2 equivalent) in 2005 in New Zealand to that in Pakistan?
Provide a succinct answer. 0.07. What is the ratio of the SF6 emissions (in thousand metric tons of CO2 equivalent) of 2008 in New Zealand to that in Pakistan?
Your answer should be compact. 0.06. What is the ratio of the SF6 emissions (in thousand metric tons of CO2 equivalent) of 1990 in New Zealand to that in Philippines?
Ensure brevity in your answer.  0.31. What is the ratio of the SF6 emissions (in thousand metric tons of CO2 equivalent) in 2000 in New Zealand to that in Philippines?
Ensure brevity in your answer.  0.26. What is the ratio of the SF6 emissions (in thousand metric tons of CO2 equivalent) of 2005 in New Zealand to that in Philippines?
Your response must be concise. 0.15. What is the ratio of the SF6 emissions (in thousand metric tons of CO2 equivalent) of 2008 in New Zealand to that in Philippines?
Provide a succinct answer. 0.15. What is the ratio of the SF6 emissions (in thousand metric tons of CO2 equivalent) of 1990 in New Zealand to that in Poland?
Provide a succinct answer. 0.47. What is the ratio of the SF6 emissions (in thousand metric tons of CO2 equivalent) of 2000 in New Zealand to that in Poland?
Offer a terse response. 0.31. What is the ratio of the SF6 emissions (in thousand metric tons of CO2 equivalent) of 2005 in New Zealand to that in Poland?
Your response must be concise. 0.24. What is the ratio of the SF6 emissions (in thousand metric tons of CO2 equivalent) in 2008 in New Zealand to that in Poland?
Offer a very short reply. 0.24. What is the ratio of the SF6 emissions (in thousand metric tons of CO2 equivalent) of 1990 in Nigeria to that in Norway?
Your response must be concise. 0.11. What is the ratio of the SF6 emissions (in thousand metric tons of CO2 equivalent) in 2000 in Nigeria to that in Norway?
Your response must be concise. 0.19. What is the ratio of the SF6 emissions (in thousand metric tons of CO2 equivalent) of 2005 in Nigeria to that in Norway?
Provide a short and direct response. 0.99. What is the ratio of the SF6 emissions (in thousand metric tons of CO2 equivalent) of 2008 in Nigeria to that in Norway?
Ensure brevity in your answer.  1.76. What is the ratio of the SF6 emissions (in thousand metric tons of CO2 equivalent) in 1990 in Nigeria to that in Pakistan?
Ensure brevity in your answer.  0.24. What is the ratio of the SF6 emissions (in thousand metric tons of CO2 equivalent) in 2000 in Nigeria to that in Pakistan?
Your answer should be very brief. 0.53. What is the ratio of the SF6 emissions (in thousand metric tons of CO2 equivalent) of 2005 in Nigeria to that in Pakistan?
Give a very brief answer. 0.4. What is the ratio of the SF6 emissions (in thousand metric tons of CO2 equivalent) in 2008 in Nigeria to that in Pakistan?
Your answer should be compact. 0.41. What is the ratio of the SF6 emissions (in thousand metric tons of CO2 equivalent) of 1990 in Nigeria to that in Philippines?
Make the answer very short. 1.49. What is the ratio of the SF6 emissions (in thousand metric tons of CO2 equivalent) in 2000 in Nigeria to that in Philippines?
Make the answer very short. 0.83. What is the ratio of the SF6 emissions (in thousand metric tons of CO2 equivalent) of 2005 in Nigeria to that in Philippines?
Give a very brief answer. 0.89. What is the ratio of the SF6 emissions (in thousand metric tons of CO2 equivalent) in 2008 in Nigeria to that in Philippines?
Your answer should be very brief. 0.93. What is the ratio of the SF6 emissions (in thousand metric tons of CO2 equivalent) in 1990 in Nigeria to that in Poland?
Offer a very short reply. 2.32. What is the ratio of the SF6 emissions (in thousand metric tons of CO2 equivalent) of 2000 in Nigeria to that in Poland?
Offer a terse response. 0.96. What is the ratio of the SF6 emissions (in thousand metric tons of CO2 equivalent) of 2005 in Nigeria to that in Poland?
Offer a very short reply. 1.49. What is the ratio of the SF6 emissions (in thousand metric tons of CO2 equivalent) in 2008 in Nigeria to that in Poland?
Your answer should be very brief. 1.55. What is the ratio of the SF6 emissions (in thousand metric tons of CO2 equivalent) in 1990 in Norway to that in Pakistan?
Ensure brevity in your answer.  2.24. What is the ratio of the SF6 emissions (in thousand metric tons of CO2 equivalent) of 2000 in Norway to that in Pakistan?
Offer a terse response. 2.83. What is the ratio of the SF6 emissions (in thousand metric tons of CO2 equivalent) of 2005 in Norway to that in Pakistan?
Offer a very short reply. 0.4. What is the ratio of the SF6 emissions (in thousand metric tons of CO2 equivalent) in 2008 in Norway to that in Pakistan?
Make the answer very short. 0.23. What is the ratio of the SF6 emissions (in thousand metric tons of CO2 equivalent) in 1990 in Norway to that in Philippines?
Give a very brief answer. 13.98. What is the ratio of the SF6 emissions (in thousand metric tons of CO2 equivalent) of 2000 in Norway to that in Philippines?
Keep it short and to the point. 4.44. What is the ratio of the SF6 emissions (in thousand metric tons of CO2 equivalent) of 2005 in Norway to that in Philippines?
Give a very brief answer. 0.91. What is the ratio of the SF6 emissions (in thousand metric tons of CO2 equivalent) in 2008 in Norway to that in Philippines?
Keep it short and to the point. 0.53. What is the ratio of the SF6 emissions (in thousand metric tons of CO2 equivalent) of 1990 in Norway to that in Poland?
Your response must be concise. 21.7. What is the ratio of the SF6 emissions (in thousand metric tons of CO2 equivalent) in 2000 in Norway to that in Poland?
Give a very brief answer. 5.18. What is the ratio of the SF6 emissions (in thousand metric tons of CO2 equivalent) in 2005 in Norway to that in Poland?
Your answer should be very brief. 1.52. What is the ratio of the SF6 emissions (in thousand metric tons of CO2 equivalent) in 2008 in Norway to that in Poland?
Your answer should be compact. 0.88. What is the ratio of the SF6 emissions (in thousand metric tons of CO2 equivalent) of 1990 in Pakistan to that in Philippines?
Offer a very short reply. 6.23. What is the ratio of the SF6 emissions (in thousand metric tons of CO2 equivalent) of 2000 in Pakistan to that in Philippines?
Make the answer very short. 1.57. What is the ratio of the SF6 emissions (in thousand metric tons of CO2 equivalent) in 2005 in Pakistan to that in Philippines?
Your response must be concise. 2.24. What is the ratio of the SF6 emissions (in thousand metric tons of CO2 equivalent) in 2008 in Pakistan to that in Philippines?
Your answer should be very brief. 2.26. What is the ratio of the SF6 emissions (in thousand metric tons of CO2 equivalent) in 1990 in Pakistan to that in Poland?
Your answer should be compact. 9.67. What is the ratio of the SF6 emissions (in thousand metric tons of CO2 equivalent) in 2000 in Pakistan to that in Poland?
Offer a very short reply. 1.83. What is the ratio of the SF6 emissions (in thousand metric tons of CO2 equivalent) in 2005 in Pakistan to that in Poland?
Give a very brief answer. 3.75. What is the ratio of the SF6 emissions (in thousand metric tons of CO2 equivalent) of 2008 in Pakistan to that in Poland?
Your answer should be very brief. 3.78. What is the ratio of the SF6 emissions (in thousand metric tons of CO2 equivalent) of 1990 in Philippines to that in Poland?
Make the answer very short. 1.55. What is the ratio of the SF6 emissions (in thousand metric tons of CO2 equivalent) in 2000 in Philippines to that in Poland?
Keep it short and to the point. 1.17. What is the ratio of the SF6 emissions (in thousand metric tons of CO2 equivalent) in 2005 in Philippines to that in Poland?
Your answer should be compact. 1.67. What is the ratio of the SF6 emissions (in thousand metric tons of CO2 equivalent) in 2008 in Philippines to that in Poland?
Make the answer very short. 1.68. What is the difference between the highest and the second highest SF6 emissions (in thousand metric tons of CO2 equivalent) in 1990?
Provide a succinct answer. 1254.6. What is the difference between the highest and the second highest SF6 emissions (in thousand metric tons of CO2 equivalent) in 2000?
Provide a succinct answer. 636. What is the difference between the highest and the second highest SF6 emissions (in thousand metric tons of CO2 equivalent) of 2005?
Provide a short and direct response. 454.1. What is the difference between the highest and the second highest SF6 emissions (in thousand metric tons of CO2 equivalent) of 2008?
Your response must be concise. 529.9. What is the difference between the highest and the lowest SF6 emissions (in thousand metric tons of CO2 equivalent) in 1990?
Give a very brief answer. 2214.2. What is the difference between the highest and the lowest SF6 emissions (in thousand metric tons of CO2 equivalent) in 2000?
Keep it short and to the point. 924.8. What is the difference between the highest and the lowest SF6 emissions (in thousand metric tons of CO2 equivalent) in 2005?
Your answer should be compact. 766. What is the difference between the highest and the lowest SF6 emissions (in thousand metric tons of CO2 equivalent) of 2008?
Your answer should be very brief. 890.1. 